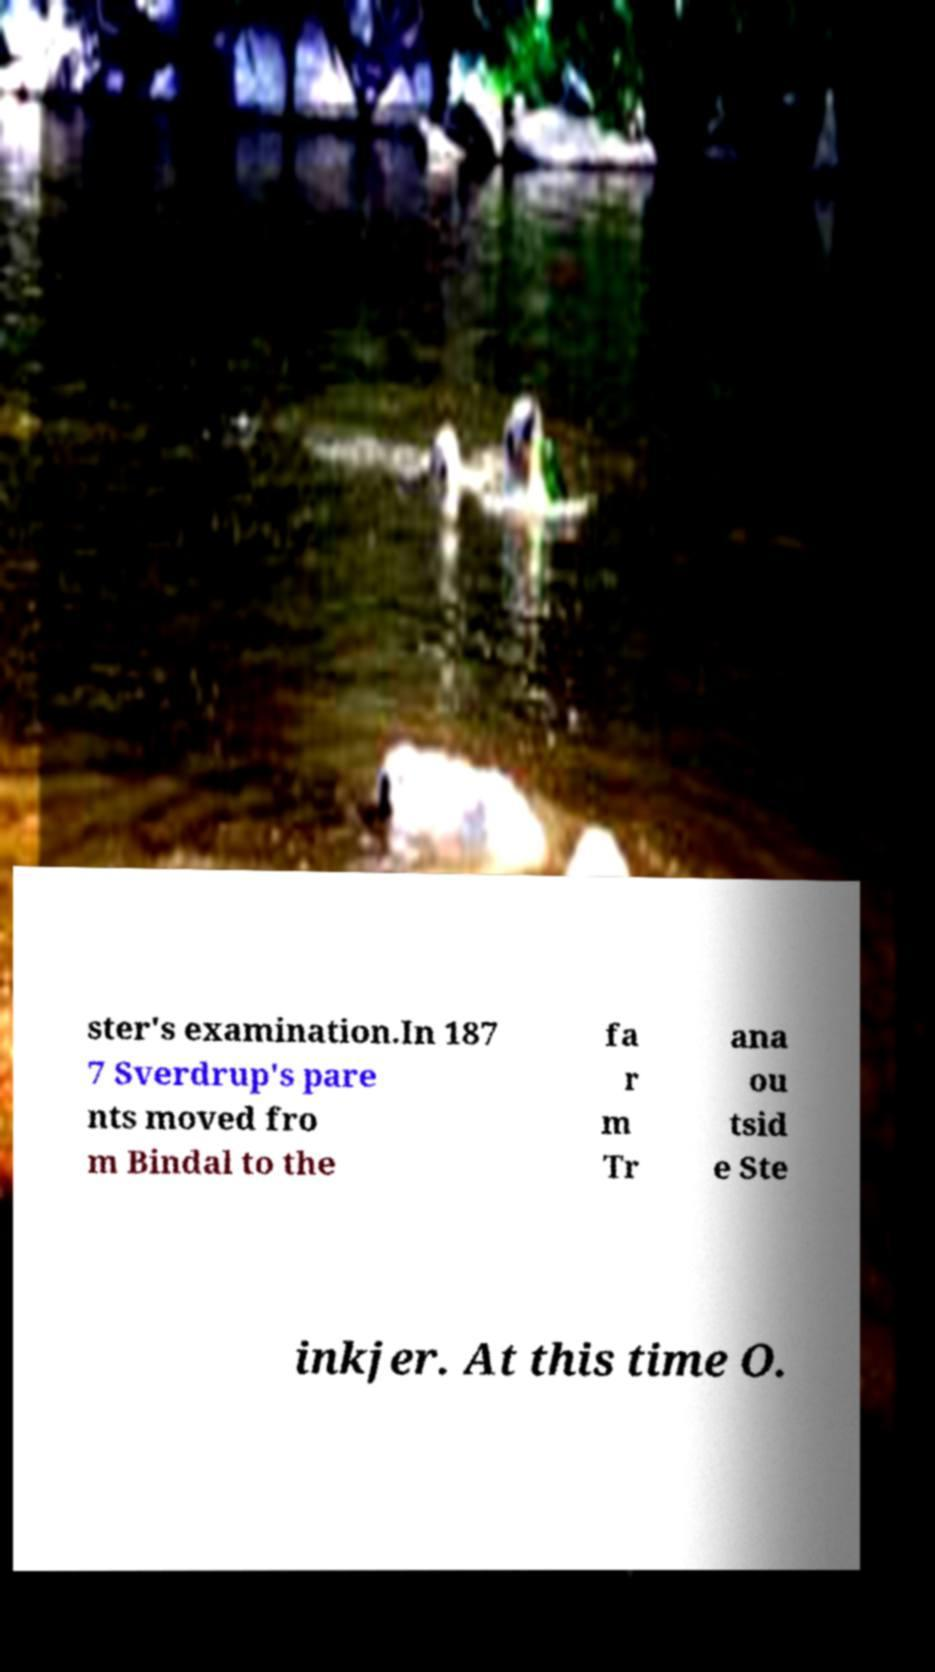Could you extract and type out the text from this image? ster's examination.In 187 7 Sverdrup's pare nts moved fro m Bindal to the fa r m Tr ana ou tsid e Ste inkjer. At this time O. 